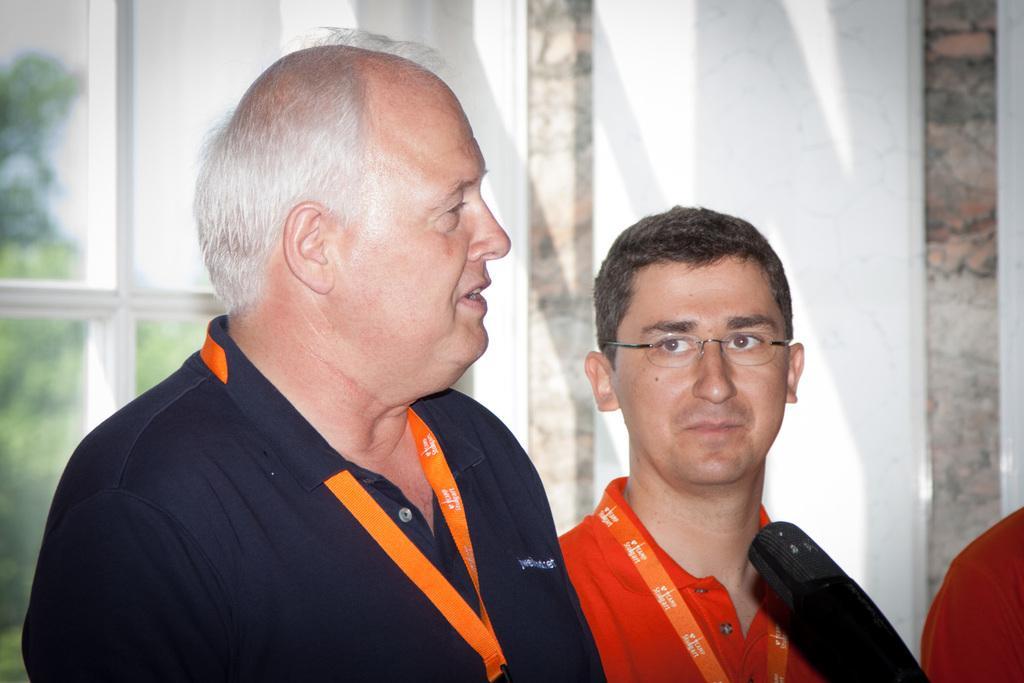In one or two sentences, can you explain what this image depicts? There are two persons. Both are wearing orange color tag. Person on the right is wearing specs. In front of them there is a mic. In the back there's a wall and glass window. 